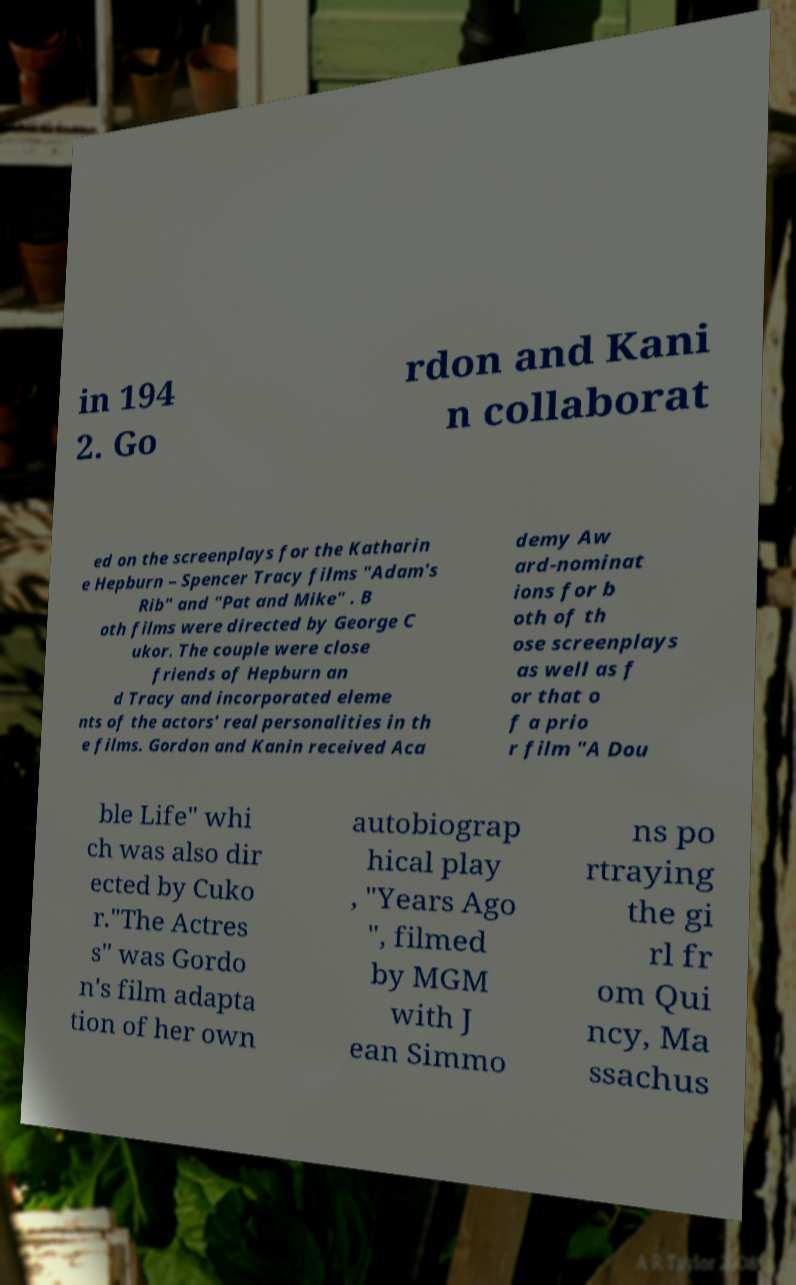There's text embedded in this image that I need extracted. Can you transcribe it verbatim? in 194 2. Go rdon and Kani n collaborat ed on the screenplays for the Katharin e Hepburn – Spencer Tracy films "Adam's Rib" and "Pat and Mike" . B oth films were directed by George C ukor. The couple were close friends of Hepburn an d Tracy and incorporated eleme nts of the actors' real personalities in th e films. Gordon and Kanin received Aca demy Aw ard-nominat ions for b oth of th ose screenplays as well as f or that o f a prio r film "A Dou ble Life" whi ch was also dir ected by Cuko r."The Actres s" was Gordo n's film adapta tion of her own autobiograp hical play , "Years Ago ", filmed by MGM with J ean Simmo ns po rtraying the gi rl fr om Qui ncy, Ma ssachus 